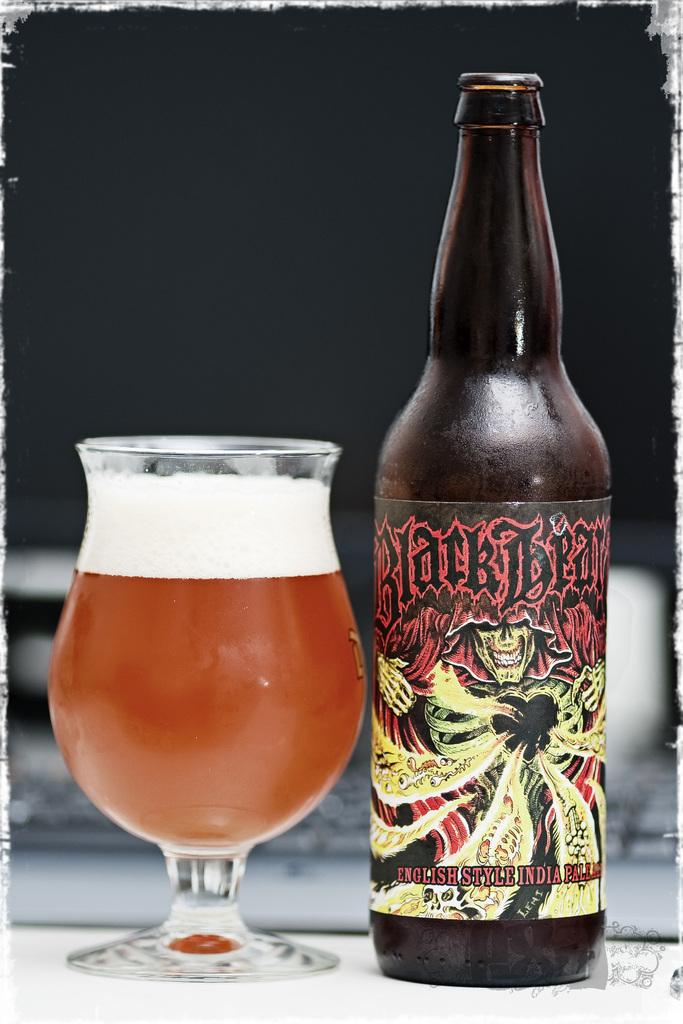<image>
Present a compact description of the photo's key features. A beer bottle from the brand Black Bear. 